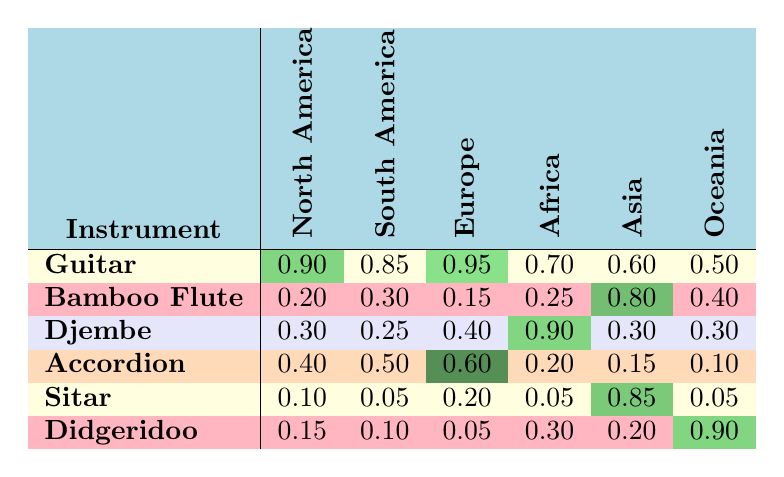What is the recognition rate of the Guitar in Africa? From the table, we can see that the recognition rate of the Guitar in Africa is noted in the corresponding cell. It shows the value of 0.70 for Africa when looking at the Guitar row.
Answer: 0.70 Which instrument has the highest recognition rate in South America? To find this, we examine all the instruments listed under the South America column. The Guitar has a recognition rate of 0.85, which is the highest compared to the Bamboo Flute at 0.30, Djembe at 0.25, Accordion at 0.50, Sitar at 0.05, and Didgeridoo at 0.10.
Answer: Guitar What is the average recognition rate of the Accordion across all regions? We sum the recognition rates of the Accordion in each region: (0.40 + 0.50 + 0.60 + 0.20 + 0.15 + 0.10) = 1.95. There are 6 regions, so the average recognition rate is 1.95 / 6 = 0.325.
Answer: 0.325 Is the recognition rate of the Djembe higher in Africa than in Europe? We look at the recognition rates for the Djembe in both Africa and Europe. In Africa, the rate is 0.90, while in Europe it is 0.40. Since 0.90 is greater than 0.40, the statement is true.
Answer: Yes Which region has the lowest recognition rate for the Didgeridoo? Analyzing the Didgeridoo row, we see the rates across the regions: North America (0.15), South America (0.10), Europe (0.05), Africa (0.30), Asia (0.20), Oceania (0.90). The lowest value is in South America at 0.10.
Answer: South America What is the difference in recognition rates for the Bamboo Flute between Asia and Europe? The Bamboo Flute has a recognition rate of 0.80 in Asia and 0.15 in Europe. To find the difference, we subtract the rate in Europe from that in Asia: 0.80 - 0.15 = 0.65.
Answer: 0.65 Does the Sitar have a recognition rate greater than 0.10 in any region? Reviewing the Sitar row, we find the recognition rates for each region: North America (0.10), South America (0.05), Europe (0.20), Africa (0.05), Asia (0.85), and Oceania (0.05). The Sitar does have rates greater than 0.10 in Europe (0.20) and Asia (0.85). Therefore, the answer is true.
Answer: Yes Which instrument has the lowest overall recognition rate? To find this, we check the recognition rates for each instrument across all regions. The lowest rates are for Bamboo Flute at 0.15 (in Europe) and Sitar (0.05 in South America and Africa) and Accordion at 0.10 in Oceania. The instrument with the lowest rate is the Sitar at 0.05.
Answer: Sitar 